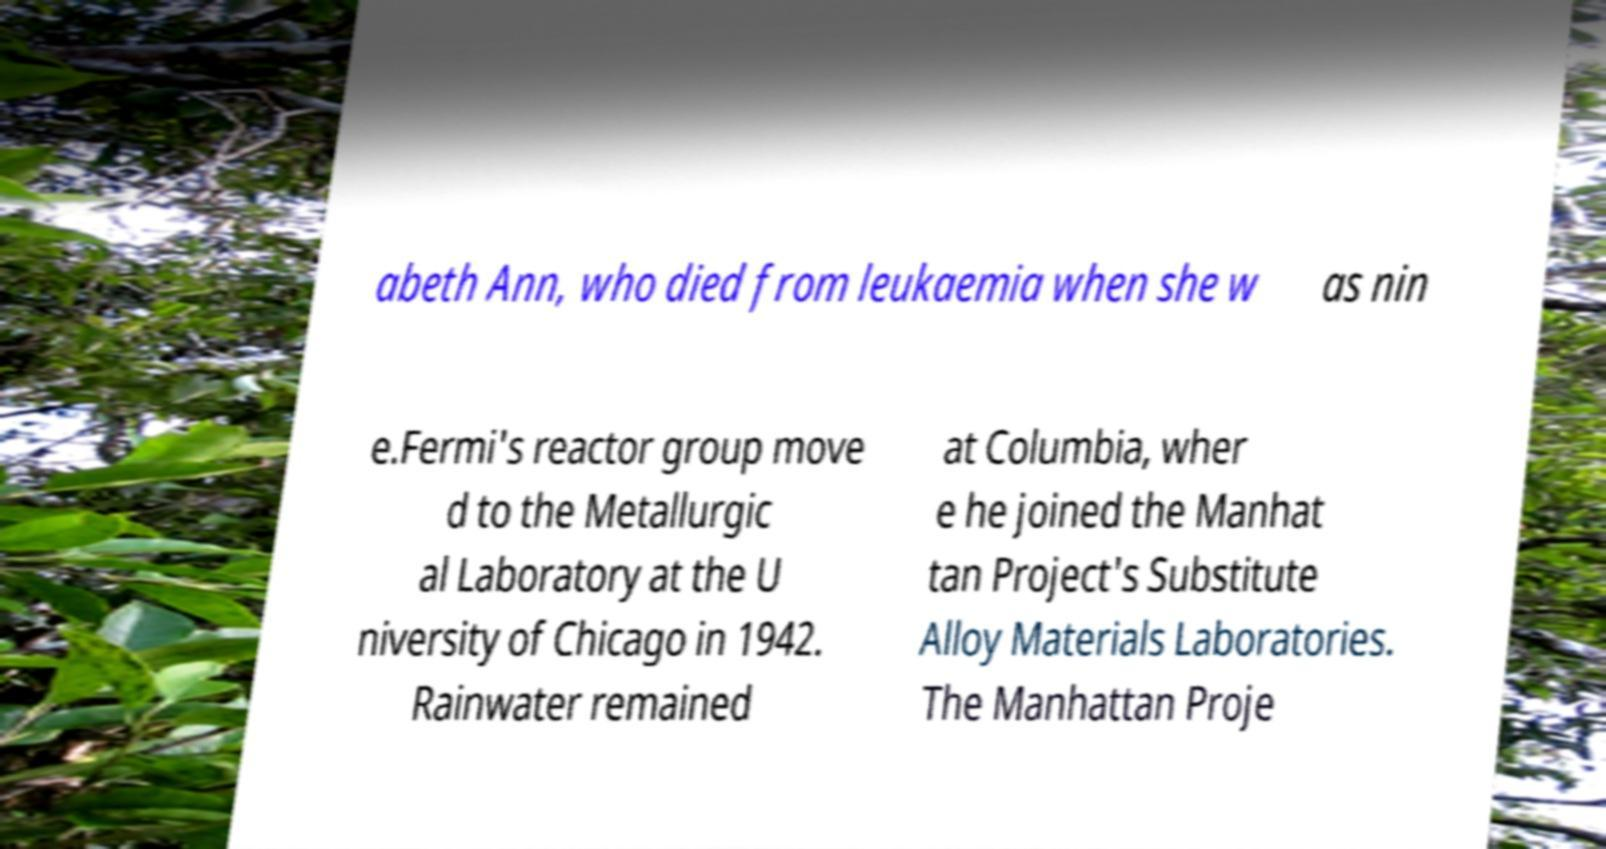What messages or text are displayed in this image? I need them in a readable, typed format. abeth Ann, who died from leukaemia when she w as nin e.Fermi's reactor group move d to the Metallurgic al Laboratory at the U niversity of Chicago in 1942. Rainwater remained at Columbia, wher e he joined the Manhat tan Project's Substitute Alloy Materials Laboratories. The Manhattan Proje 